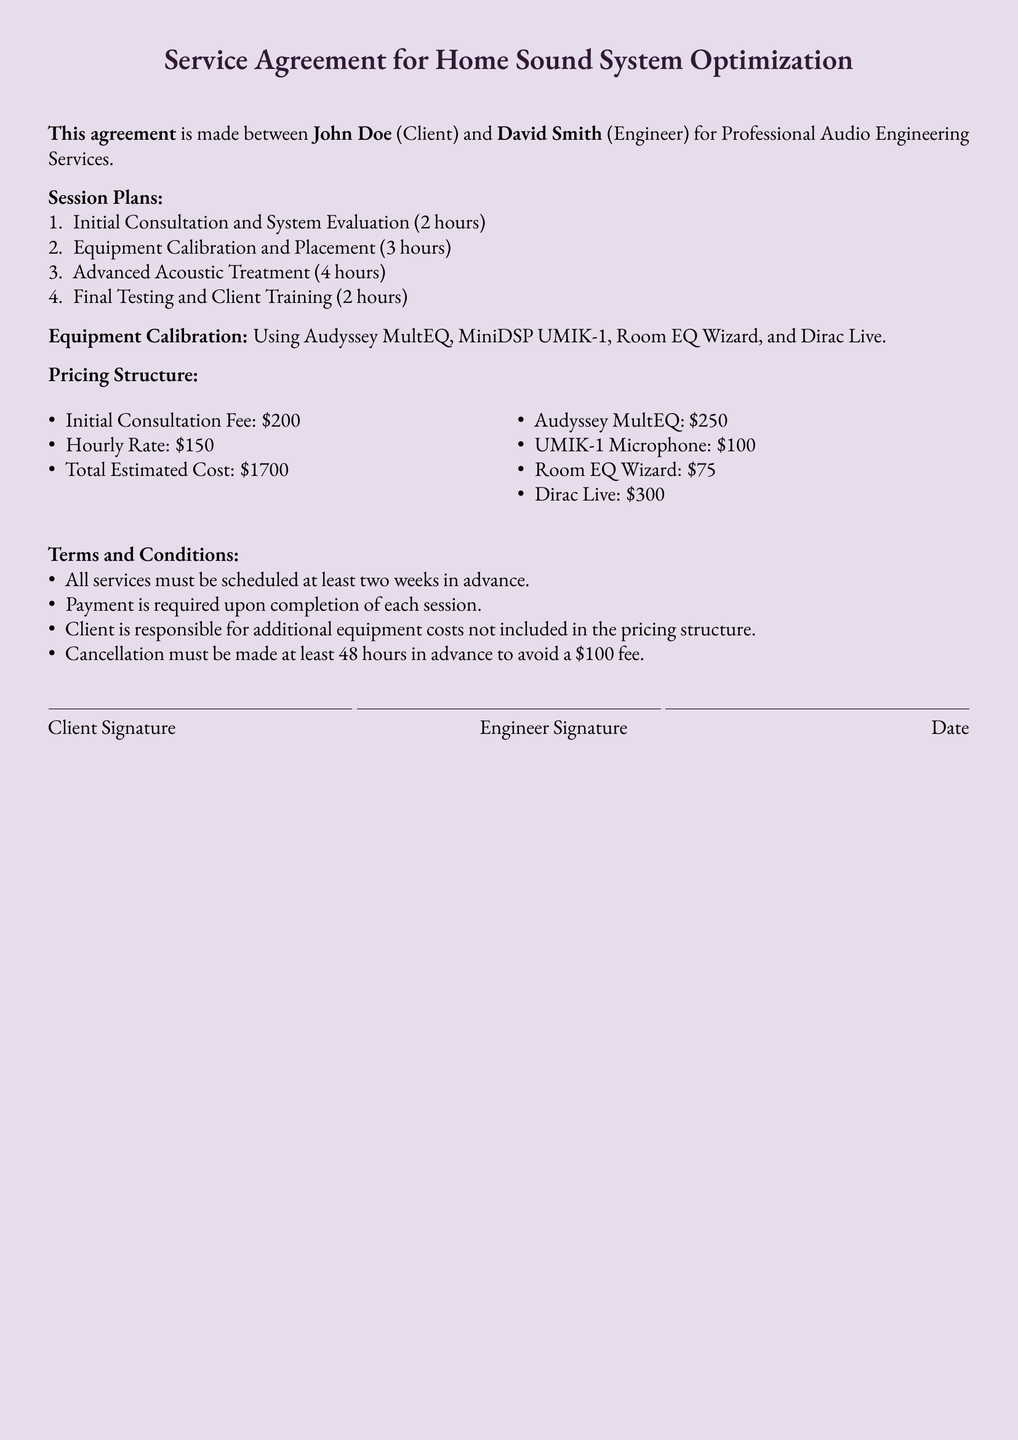What is the initial consultation duration? The document states that the Initial Consultation and System Evaluation session lasts for 2 hours.
Answer: 2 hours Who is the Engineer? The Engineer's name is mentioned in the document as David Smith.
Answer: David Smith What is the hourly rate charged by the Engineer? The hourly rate is specified in the pricing structure as $150 per hour.
Answer: $150 What is the total estimated cost for the services? The document indicates that the Total Estimated Cost is $1700.
Answer: $1700 How much is the cancellation fee if not notified on time? The cancellation fee mentioned for late cancellation is $100.
Answer: $100 What equipment is used for calibration? The document lists Audyssey MultEQ, MiniDSP UMIK-1, Room EQ Wizard, and Dirac Live as equipment for calibration.
Answer: Audyssey MultEQ, MiniDSP UMIK-1, Room EQ Wizard, Dirac Live What is the total duration of all sessions? The total duration is the sum of all session times: 2 + 3 + 4 + 2 = 11 hours.
Answer: 11 hours When must services be scheduled? The document requires that all services must be scheduled at least two weeks in advance.
Answer: Two weeks in advance 